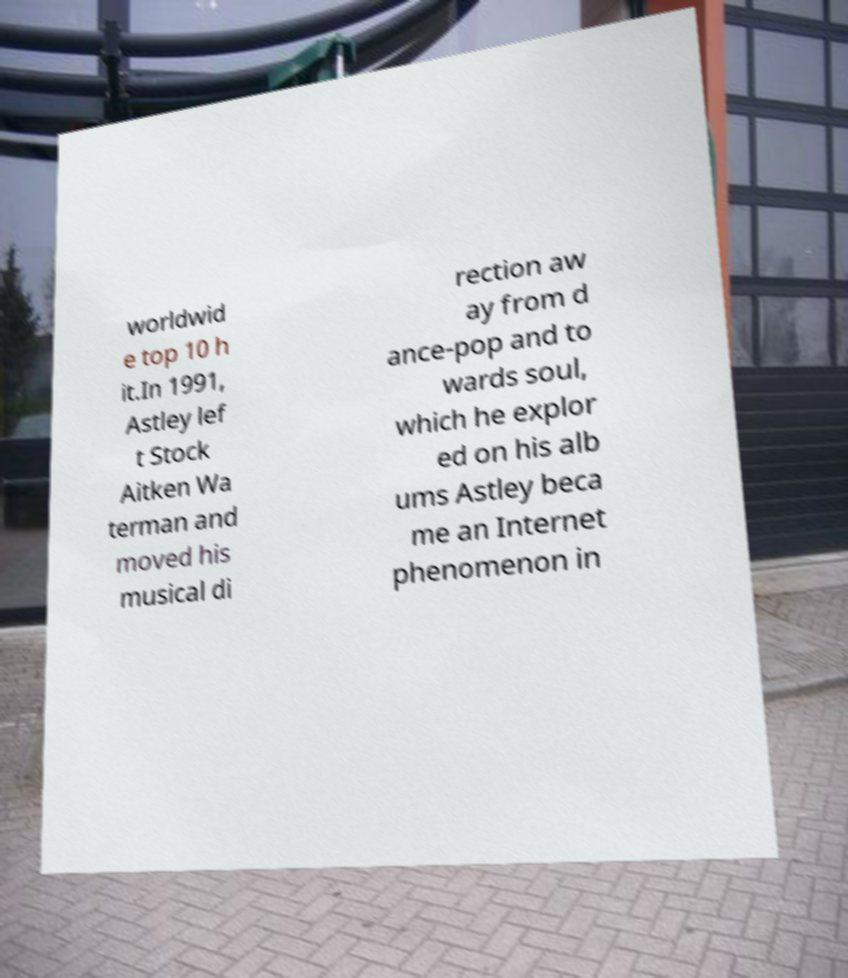Can you accurately transcribe the text from the provided image for me? worldwid e top 10 h it.In 1991, Astley lef t Stock Aitken Wa terman and moved his musical di rection aw ay from d ance-pop and to wards soul, which he explor ed on his alb ums Astley beca me an Internet phenomenon in 